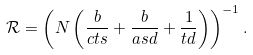<formula> <loc_0><loc_0><loc_500><loc_500>\mathcal { R } = \left ( N \left ( \frac { b } { c t s } + \frac { b } { a s d } + \frac { 1 } { t d } \right ) \right ) ^ { - 1 } .</formula> 